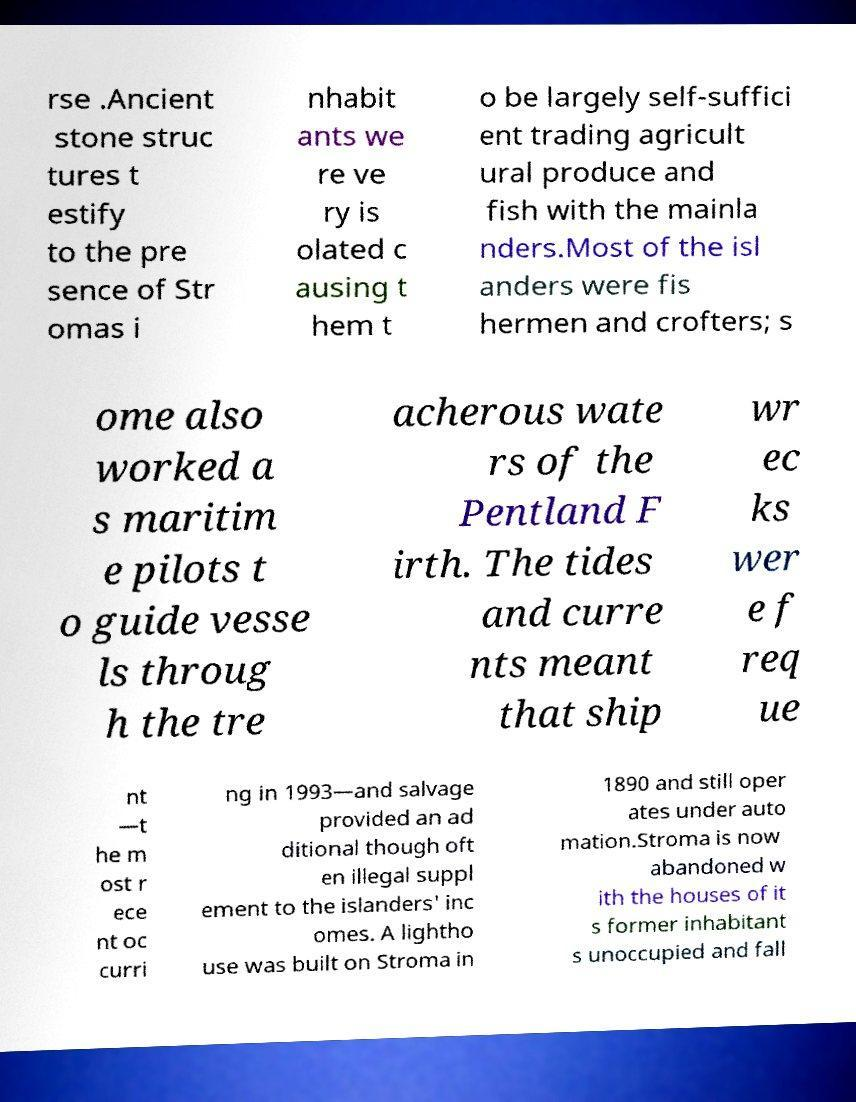What messages or text are displayed in this image? I need them in a readable, typed format. rse .Ancient stone struc tures t estify to the pre sence of Str omas i nhabit ants we re ve ry is olated c ausing t hem t o be largely self-suffici ent trading agricult ural produce and fish with the mainla nders.Most of the isl anders were fis hermen and crofters; s ome also worked a s maritim e pilots t o guide vesse ls throug h the tre acherous wate rs of the Pentland F irth. The tides and curre nts meant that ship wr ec ks wer e f req ue nt —t he m ost r ece nt oc curri ng in 1993—and salvage provided an ad ditional though oft en illegal suppl ement to the islanders' inc omes. A lightho use was built on Stroma in 1890 and still oper ates under auto mation.Stroma is now abandoned w ith the houses of it s former inhabitant s unoccupied and fall 